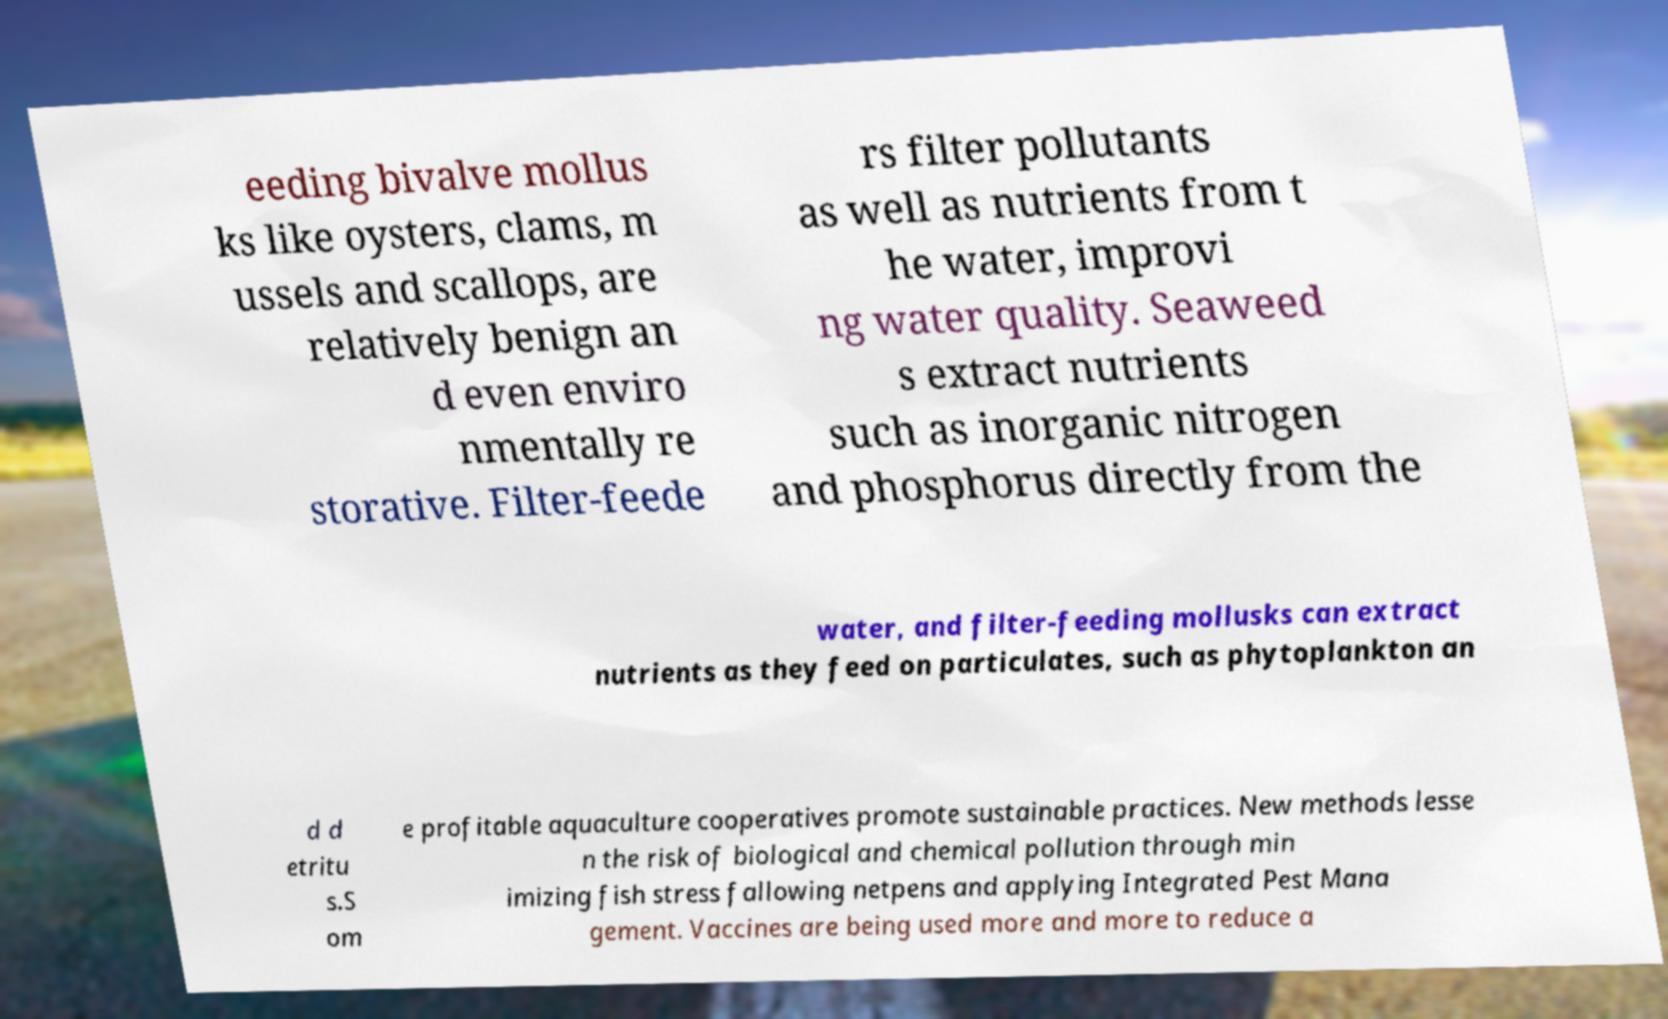I need the written content from this picture converted into text. Can you do that? eeding bivalve mollus ks like oysters, clams, m ussels and scallops, are relatively benign an d even enviro nmentally re storative. Filter-feede rs filter pollutants as well as nutrients from t he water, improvi ng water quality. Seaweed s extract nutrients such as inorganic nitrogen and phosphorus directly from the water, and filter-feeding mollusks can extract nutrients as they feed on particulates, such as phytoplankton an d d etritu s.S om e profitable aquaculture cooperatives promote sustainable practices. New methods lesse n the risk of biological and chemical pollution through min imizing fish stress fallowing netpens and applying Integrated Pest Mana gement. Vaccines are being used more and more to reduce a 